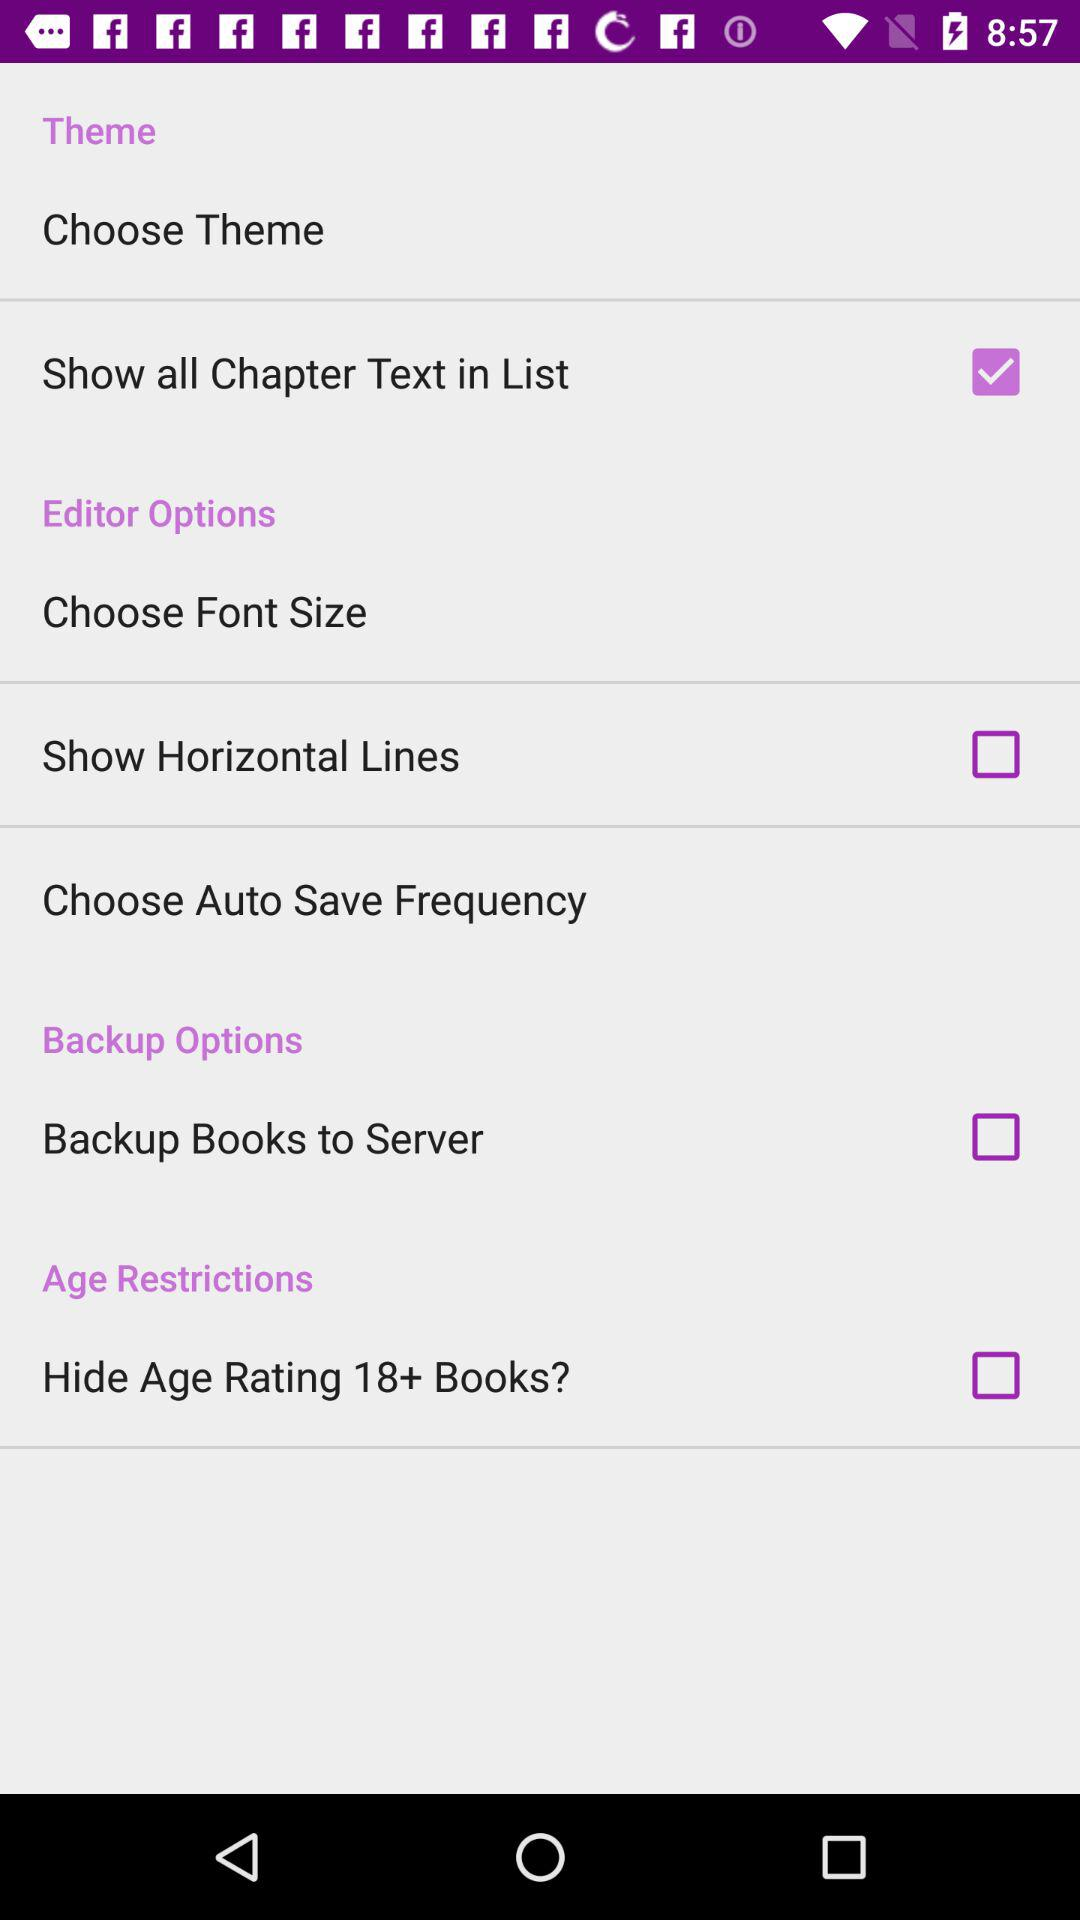What's the status of "Backup Books to Server"? The status of "Backup Books to Server" is "off". 